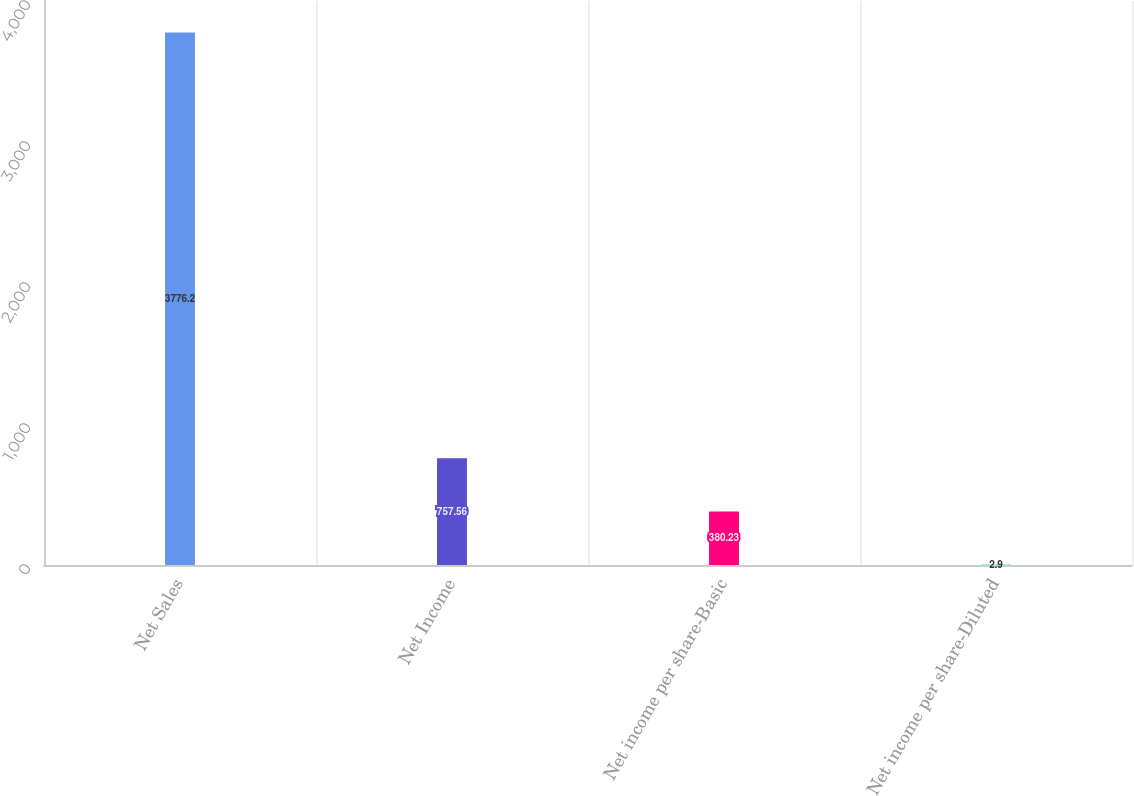<chart> <loc_0><loc_0><loc_500><loc_500><bar_chart><fcel>Net Sales<fcel>Net Income<fcel>Net income per share-Basic<fcel>Net income per share-Diluted<nl><fcel>3776.2<fcel>757.56<fcel>380.23<fcel>2.9<nl></chart> 